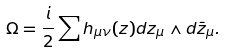<formula> <loc_0><loc_0><loc_500><loc_500>\Omega = \frac { i } { 2 } \sum h _ { \mu \nu } ( z ) d z _ { \mu } \wedge d \bar { z } _ { \mu } .</formula> 